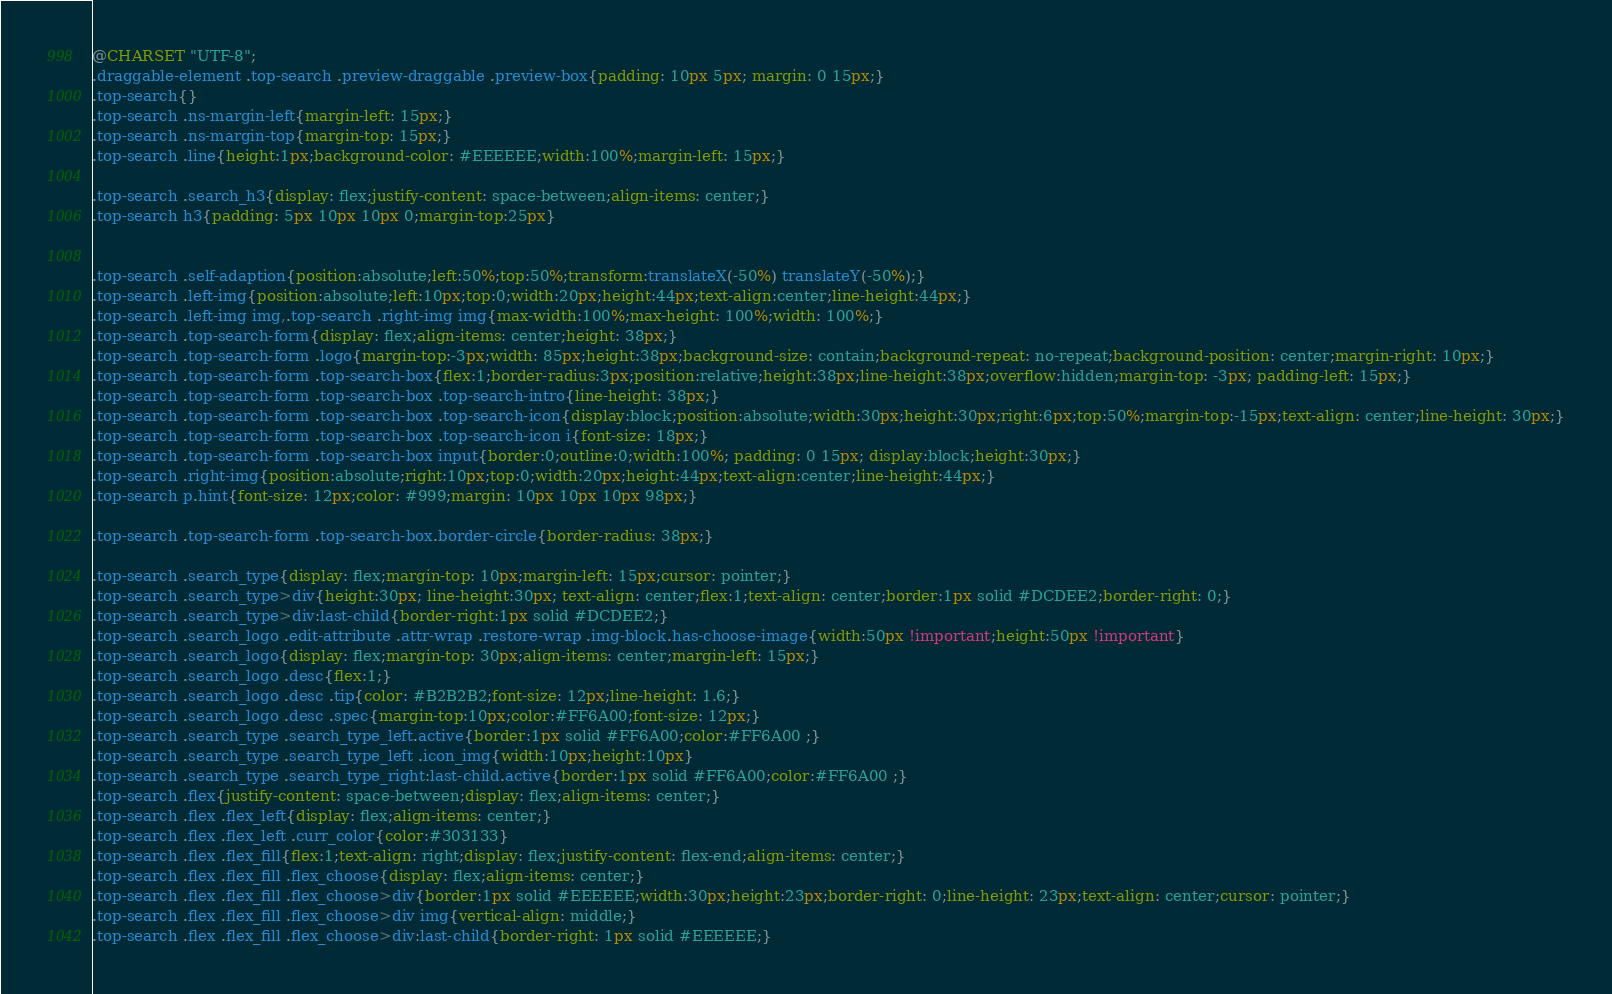Convert code to text. <code><loc_0><loc_0><loc_500><loc_500><_CSS_>@CHARSET "UTF-8";
.draggable-element .top-search .preview-draggable .preview-box{padding: 10px 5px; margin: 0 15px;}
.top-search{}
.top-search .ns-margin-left{margin-left: 15px;}
.top-search .ns-margin-top{margin-top: 15px;}
.top-search .line{height:1px;background-color: #EEEEEE;width:100%;margin-left: 15px;}

.top-search .search_h3{display: flex;justify-content: space-between;align-items: center;}
.top-search h3{padding: 5px 10px 10px 0;margin-top:25px}


.top-search .self-adaption{position:absolute;left:50%;top:50%;transform:translateX(-50%) translateY(-50%);}
.top-search .left-img{position:absolute;left:10px;top:0;width:20px;height:44px;text-align:center;line-height:44px;}
.top-search .left-img img,.top-search .right-img img{max-width:100%;max-height: 100%;width: 100%;}
.top-search .top-search-form{display: flex;align-items: center;height: 38px;}
.top-search .top-search-form .logo{margin-top:-3px;width: 85px;height:38px;background-size: contain;background-repeat: no-repeat;background-position: center;margin-right: 10px;}
.top-search .top-search-form .top-search-box{flex:1;border-radius:3px;position:relative;height:38px;line-height:38px;overflow:hidden;margin-top: -3px; padding-left: 15px;}
.top-search .top-search-form .top-search-box .top-search-intro{line-height: 38px;}
.top-search .top-search-form .top-search-box .top-search-icon{display:block;position:absolute;width:30px;height:30px;right:6px;top:50%;margin-top:-15px;text-align: center;line-height: 30px;}
.top-search .top-search-form .top-search-box .top-search-icon i{font-size: 18px;}
.top-search .top-search-form .top-search-box input{border:0;outline:0;width:100%; padding: 0 15px; display:block;height:30px;}
.top-search .right-img{position:absolute;right:10px;top:0;width:20px;height:44px;text-align:center;line-height:44px;}
.top-search p.hint{font-size: 12px;color: #999;margin: 10px 10px 10px 98px;}

.top-search .top-search-form .top-search-box.border-circle{border-radius: 38px;}

.top-search .search_type{display: flex;margin-top: 10px;margin-left: 15px;cursor: pointer;}
.top-search .search_type>div{height:30px; line-height:30px; text-align: center;flex:1;text-align: center;border:1px solid #DCDEE2;border-right: 0;}
.top-search .search_type>div:last-child{border-right:1px solid #DCDEE2;}
.top-search .search_logo .edit-attribute .attr-wrap .restore-wrap .img-block.has-choose-image{width:50px !important;height:50px !important}
.top-search .search_logo{display: flex;margin-top: 30px;align-items: center;margin-left: 15px;}
.top-search .search_logo .desc{flex:1;}
.top-search .search_logo .desc .tip{color: #B2B2B2;font-size: 12px;line-height: 1.6;}
.top-search .search_logo .desc .spec{margin-top:10px;color:#FF6A00;font-size: 12px;}
.top-search .search_type .search_type_left.active{border:1px solid #FF6A00;color:#FF6A00 ;}
.top-search .search_type .search_type_left .icon_img{width:10px;height:10px}
.top-search .search_type .search_type_right:last-child.active{border:1px solid #FF6A00;color:#FF6A00 ;}
.top-search .flex{justify-content: space-between;display: flex;align-items: center;}
.top-search .flex .flex_left{display: flex;align-items: center;}
.top-search .flex .flex_left .curr_color{color:#303133}
.top-search .flex .flex_fill{flex:1;text-align: right;display: flex;justify-content: flex-end;align-items: center;}
.top-search .flex .flex_fill .flex_choose{display: flex;align-items: center;}
.top-search .flex .flex_fill .flex_choose>div{border:1px solid #EEEEEE;width:30px;height:23px;border-right: 0;line-height: 23px;text-align: center;cursor: pointer;}
.top-search .flex .flex_fill .flex_choose>div img{vertical-align: middle;}
.top-search .flex .flex_fill .flex_choose>div:last-child{border-right: 1px solid #EEEEEE;}</code> 